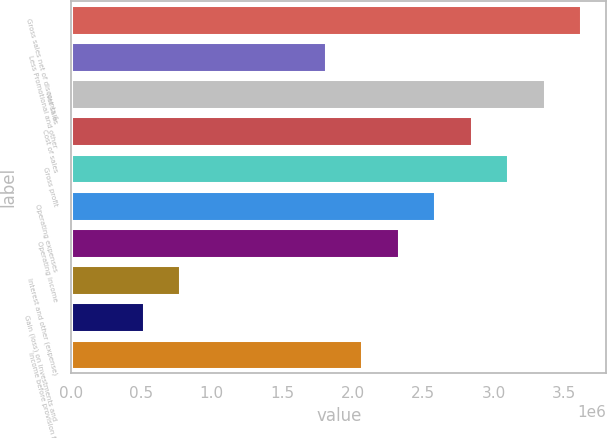Convert chart. <chart><loc_0><loc_0><loc_500><loc_500><bar_chart><fcel>Gross sales net of discounts &<fcel>Less Promotional and other<fcel>Net sales<fcel>Cost of sales<fcel>Gross profit<fcel>Operating expenses<fcel>Operating income<fcel>Interest and other (expense)<fcel>Gain (loss) on investments and<fcel>Income before provision for<nl><fcel>3.62114e+06<fcel>1.81057e+06<fcel>3.36249e+06<fcel>2.84518e+06<fcel>3.10384e+06<fcel>2.58653e+06<fcel>2.32788e+06<fcel>775961<fcel>517308<fcel>2.06923e+06<nl></chart> 